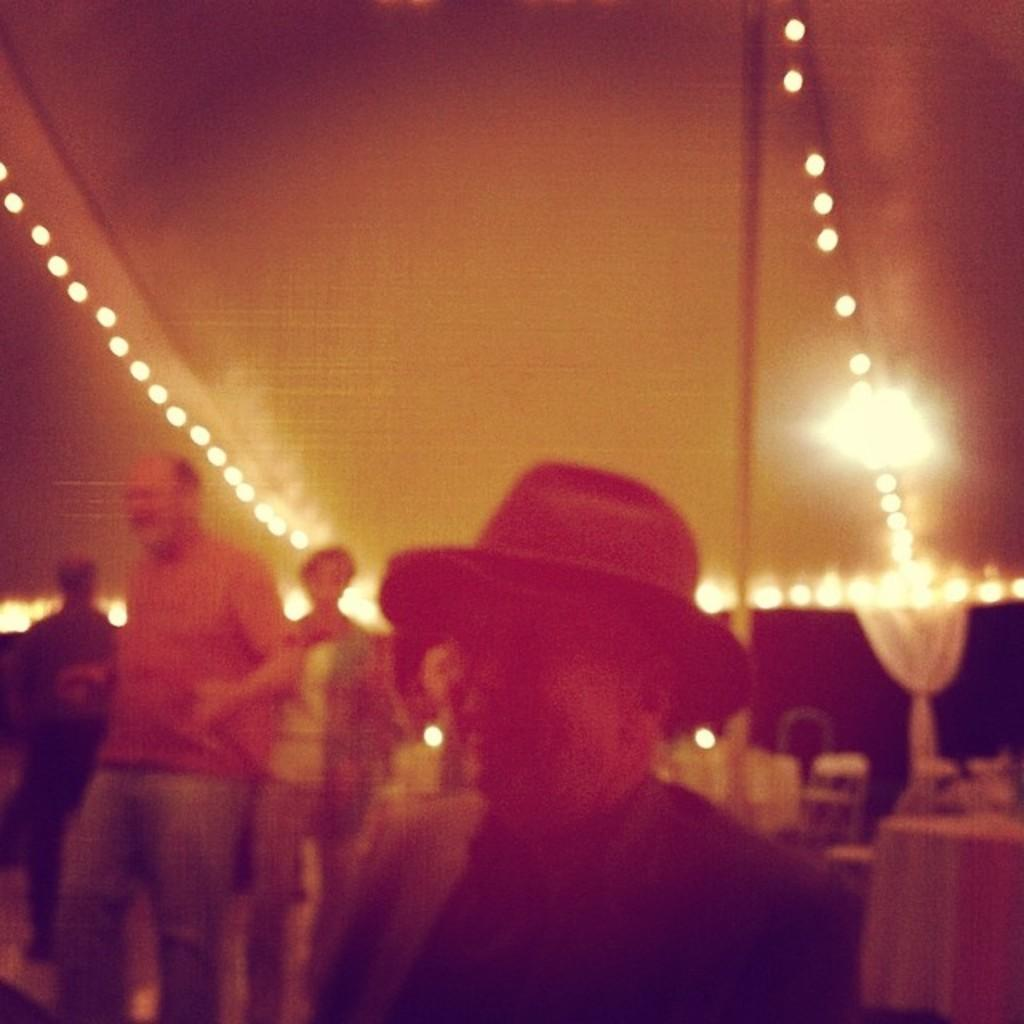What can be seen in the image? There is a group of people in the image. What are the people wearing? The people are wearing dresses. Can you describe any specific person in the image? There is a person with a hat in the image. What is present to the right in the image? There are many objects to the right in the image. What can be seen at the top of the image? There are lights visible at the top of the image. What date is marked on the calendar in the image? There is no calendar present in the image. What type of detail can be seen on the hammer in the image? There is no hammer present in the image. 